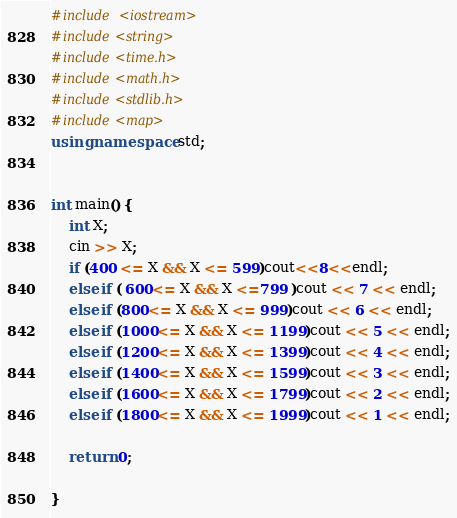<code> <loc_0><loc_0><loc_500><loc_500><_C++_>#include <iostream>
#include<string>
#include<time.h>
#include<math.h>
#include<stdlib.h>
#include<map>
using namespace std;


int main() {
	int X;
	cin >> X;
	if (400 <= X && X <= 599)cout<<8<<endl;
	else if ( 600<= X && X <=799 )cout << 7 << endl;
	else if (800<= X && X <= 999)cout << 6 << endl;
	else if (1000<= X && X <= 1199)cout << 5 << endl;
	else if (1200<= X && X <= 1399)cout << 4 << endl;
	else if (1400<= X && X <= 1599)cout << 3 << endl;
	else if (1600<= X && X <= 1799)cout << 2 << endl;
	else if (1800<= X && X <= 1999)cout << 1 << endl;

	return 0;

}</code> 